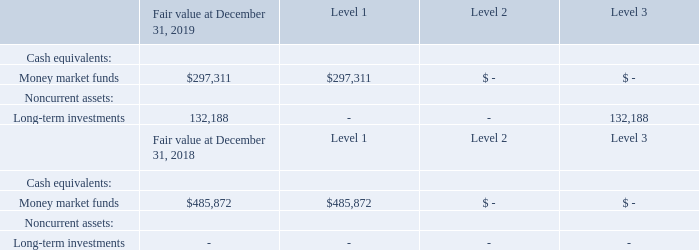Note 5. Fair Value of Financial Instruments
The Company measures and reports certain cash equivalents, including money market funds and certificates of deposit, in addition to its long-term investments at fair value in accordance with the provisions of the authoritative accounting guidance that addresses fair value measurements. This guidance establishes a hierarchy for inputs used in measuring fair value that maximizes the use of observable inputs and minimizes the use of unobservable inputs by requiring that the most observable inputs be used when available
The hierarchy is broken down into three levels based on the reliability of the inputs as follows:
Level 1: Observable inputs that reflect unadjusted quoted prices in active markets for identical assets or liabilities
Level 2: Other inputs, such as quoted prices for similar assets or liabilities, quoted prices for identical or similar assets or liabilities in inactive markets, or other inputs that are observable or can be corroborated by observable market data for substantially the full term of the asset or liability
Level 3: Unobservable inputs that are supported by little or no market activity and that are based on management’s assumptions, including fair value measurements determined by using pricing models, discounted cash flow methodologies or similar techniques
The financial assets carried at fair value were determined using the following inputs (in thousands):
The Company’s other financial instruments, including accounts receivable, accounts payable, and other current liabilities, are carried at cost, which approximates fair-value due to the relatively short maturity of those instruments.
What does Level 1 input in the fair value hierarchy refer to? Observable inputs that reflect unadjusted quoted prices in active markets for identical assets or liabilities. What does Level 2 input in the fair value hierarchy refer to? Other inputs, such as quoted prices for similar assets or liabilities, quoted prices for identical or similar assets or liabilities in inactive markets, or other inputs that are observable or can be corroborated by observable market data for substantially the full term of the asset or liability. What does Level 3 input in the fair value hierarchy refer to? Unobservable inputs that are supported by little or no market activity and that are based on management’s assumptions. What is the total fair value of money market funds and long-term investments at December 31, 2019?
Answer scale should be: thousand. 297,311 + 132,188 
Answer: 429499. What is the total value of money market funds in 2018 and 2019?
Answer scale should be: thousand. 297,311 + 485,872 
Answer: 783183. What is the percentage change in the company's money market funds between 2018 and 2019?
Answer scale should be: percent. (297,311 - 485,872)/485,872 
Answer: -38.81. 